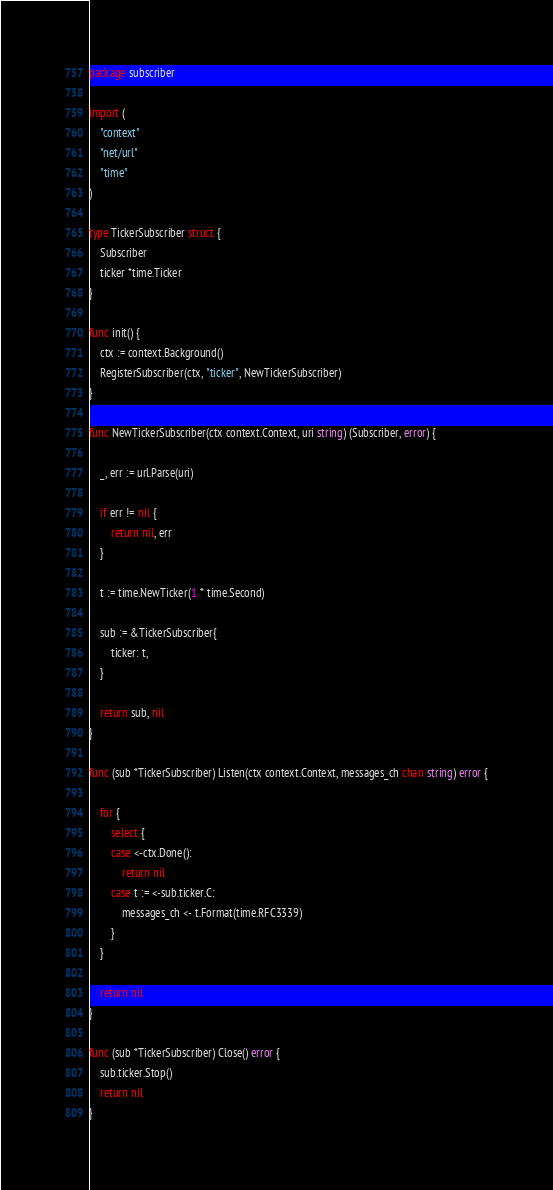<code> <loc_0><loc_0><loc_500><loc_500><_Go_>package subscriber

import (
	"context"
	"net/url"
	"time"
)

type TickerSubscriber struct {
	Subscriber
	ticker *time.Ticker
}

func init() {
	ctx := context.Background()
	RegisterSubscriber(ctx, "ticker", NewTickerSubscriber)
}

func NewTickerSubscriber(ctx context.Context, uri string) (Subscriber, error) {

	_, err := url.Parse(uri)

	if err != nil {
		return nil, err
	}

	t := time.NewTicker(1 * time.Second)

	sub := &TickerSubscriber{
		ticker: t,
	}

	return sub, nil
}

func (sub *TickerSubscriber) Listen(ctx context.Context, messages_ch chan string) error {

	for {
		select {
		case <-ctx.Done():
			return nil
		case t := <-sub.ticker.C:
			messages_ch <- t.Format(time.RFC3339)
		}
	}

	return nil
}

func (sub *TickerSubscriber) Close() error {
	sub.ticker.Stop()
	return nil
}
</code> 